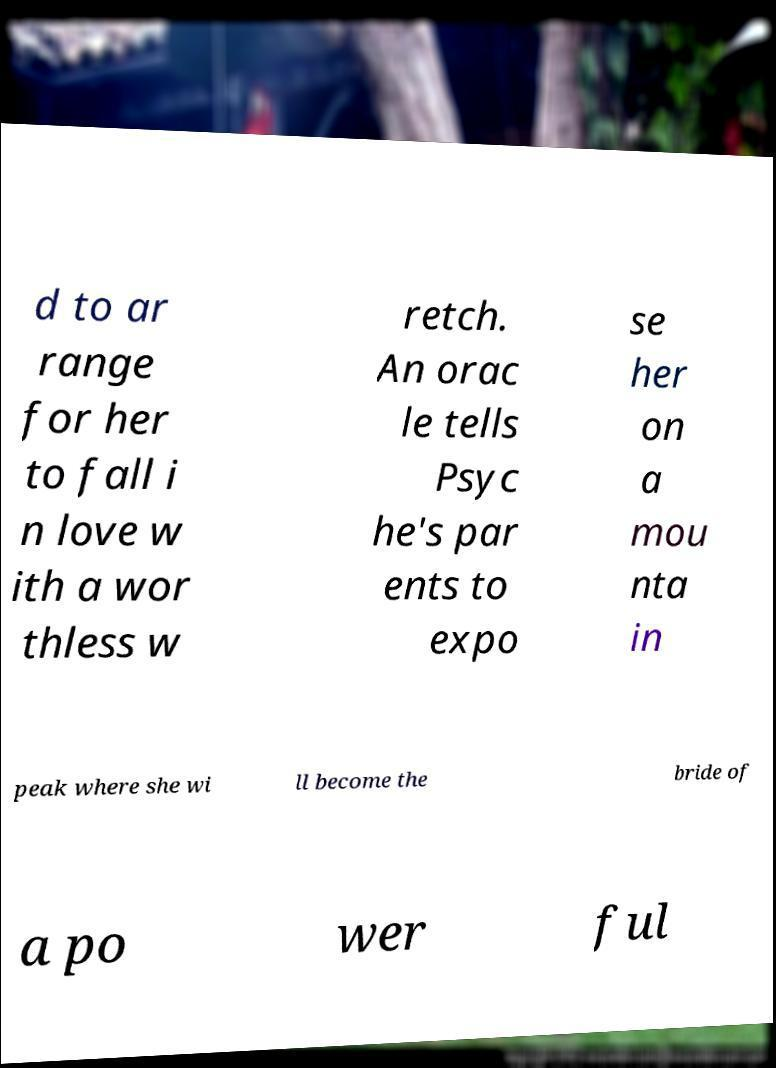I need the written content from this picture converted into text. Can you do that? d to ar range for her to fall i n love w ith a wor thless w retch. An orac le tells Psyc he's par ents to expo se her on a mou nta in peak where she wi ll become the bride of a po wer ful 